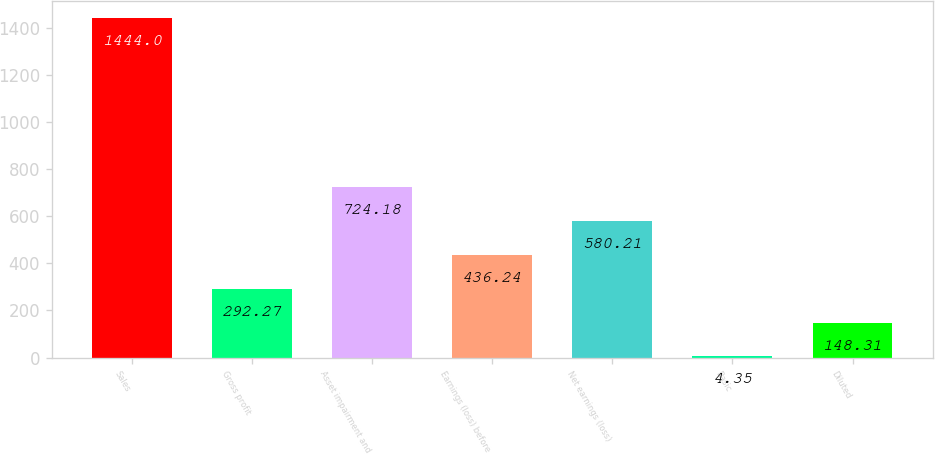<chart> <loc_0><loc_0><loc_500><loc_500><bar_chart><fcel>Sales<fcel>Gross profit<fcel>Asset impairment and<fcel>Earnings (loss) before<fcel>Net earnings (loss)<fcel>Basic<fcel>Diluted<nl><fcel>1444<fcel>292.27<fcel>724.18<fcel>436.24<fcel>580.21<fcel>4.35<fcel>148.31<nl></chart> 